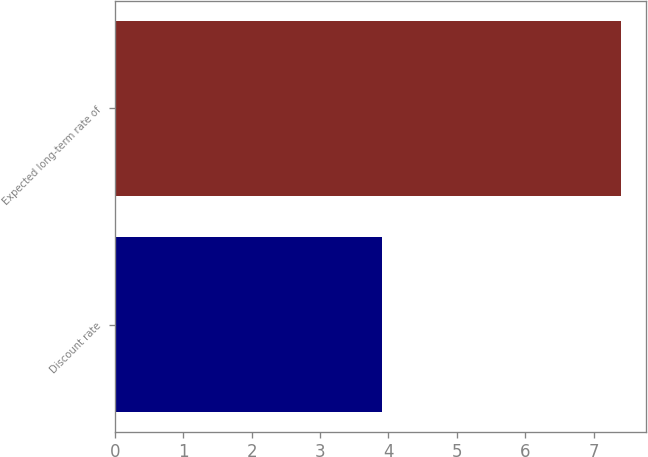Convert chart. <chart><loc_0><loc_0><loc_500><loc_500><bar_chart><fcel>Discount rate<fcel>Expected long-term rate of<nl><fcel>3.9<fcel>7.4<nl></chart> 